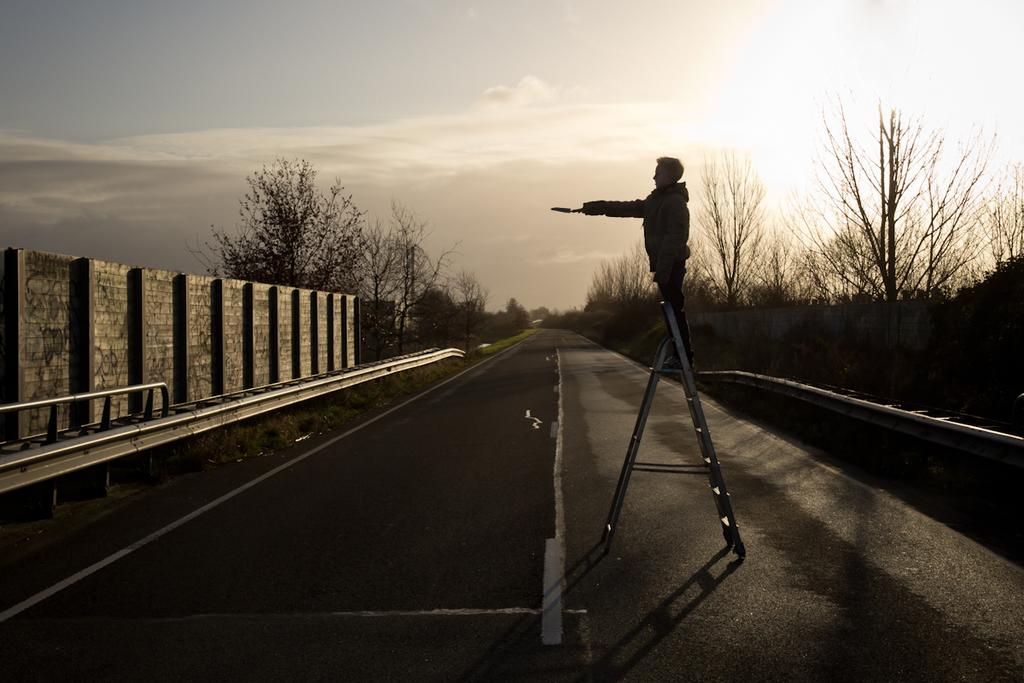What is the main subject of the image? There is a person in the image. What is the person doing in the image? The person is holding an object and standing on a ladder. What type of surface is visible beneath the person? There is ground visible in the image. What type of vegetation can be seen in the image? There are trees and grass in the image. What is visible in the background of the image? The sky is visible in the image, and clouds are present in the sky. What type of button can be seen on the person's shirt in the image? There is no button visible on the person's shirt in the image. How many cherries are hanging from the trees in the image? There are no cherries present in the image; only trees and grass are visible. 